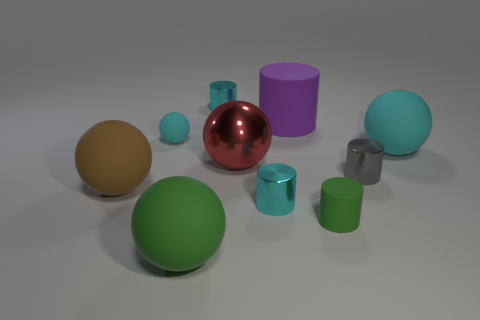Is there a gray rubber cube that has the same size as the brown rubber thing?
Your answer should be compact. No. Are there fewer big rubber spheres that are behind the large brown object than big balls?
Give a very brief answer. Yes. Is the size of the brown ball the same as the purple matte cylinder?
Offer a terse response. Yes. What is the size of the green sphere that is the same material as the big purple object?
Your answer should be compact. Large. What number of big rubber balls are the same color as the metal sphere?
Keep it short and to the point. 0. Is the number of large objects that are to the right of the large green ball less than the number of big things on the right side of the brown thing?
Your answer should be very brief. Yes. There is a green object that is left of the metallic sphere; is its shape the same as the big brown object?
Provide a succinct answer. Yes. Is there anything else that is the same material as the large purple thing?
Keep it short and to the point. Yes. Do the big thing that is to the right of the gray metal object and the big purple object have the same material?
Offer a terse response. Yes. There is a cylinder on the right side of the small matte object in front of the small thing right of the small green rubber cylinder; what is its material?
Make the answer very short. Metal. 